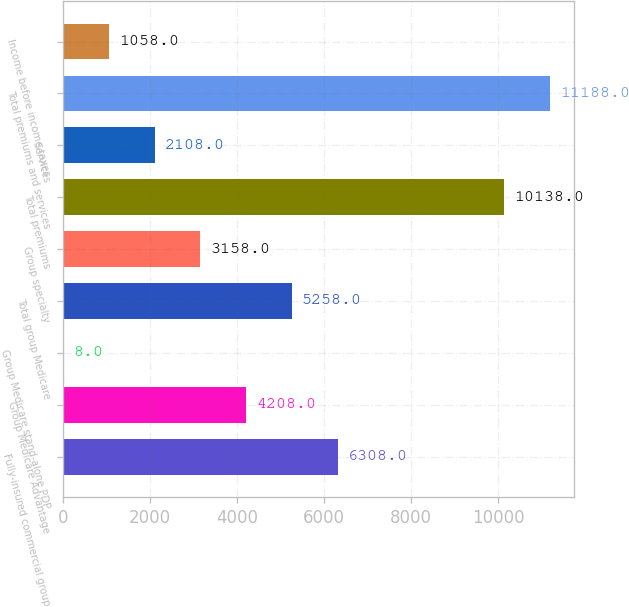Convert chart. <chart><loc_0><loc_0><loc_500><loc_500><bar_chart><fcel>Fully-insured commercial group<fcel>Group Medicare Advantage<fcel>Group Medicare stand-alone PDP<fcel>Total group Medicare<fcel>Group specialty<fcel>Total premiums<fcel>Services<fcel>Total premiums and services<fcel>Income before income taxes<nl><fcel>6308<fcel>4208<fcel>8<fcel>5258<fcel>3158<fcel>10138<fcel>2108<fcel>11188<fcel>1058<nl></chart> 